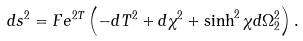Convert formula to latex. <formula><loc_0><loc_0><loc_500><loc_500>d s ^ { 2 } = F e ^ { 2 T } \left ( - d T ^ { 2 } + d \chi ^ { 2 } + \sinh ^ { 2 } \chi d \Omega _ { 2 } ^ { 2 } \right ) .</formula> 